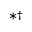<formula> <loc_0><loc_0><loc_500><loc_500>\ast \dagger</formula> 